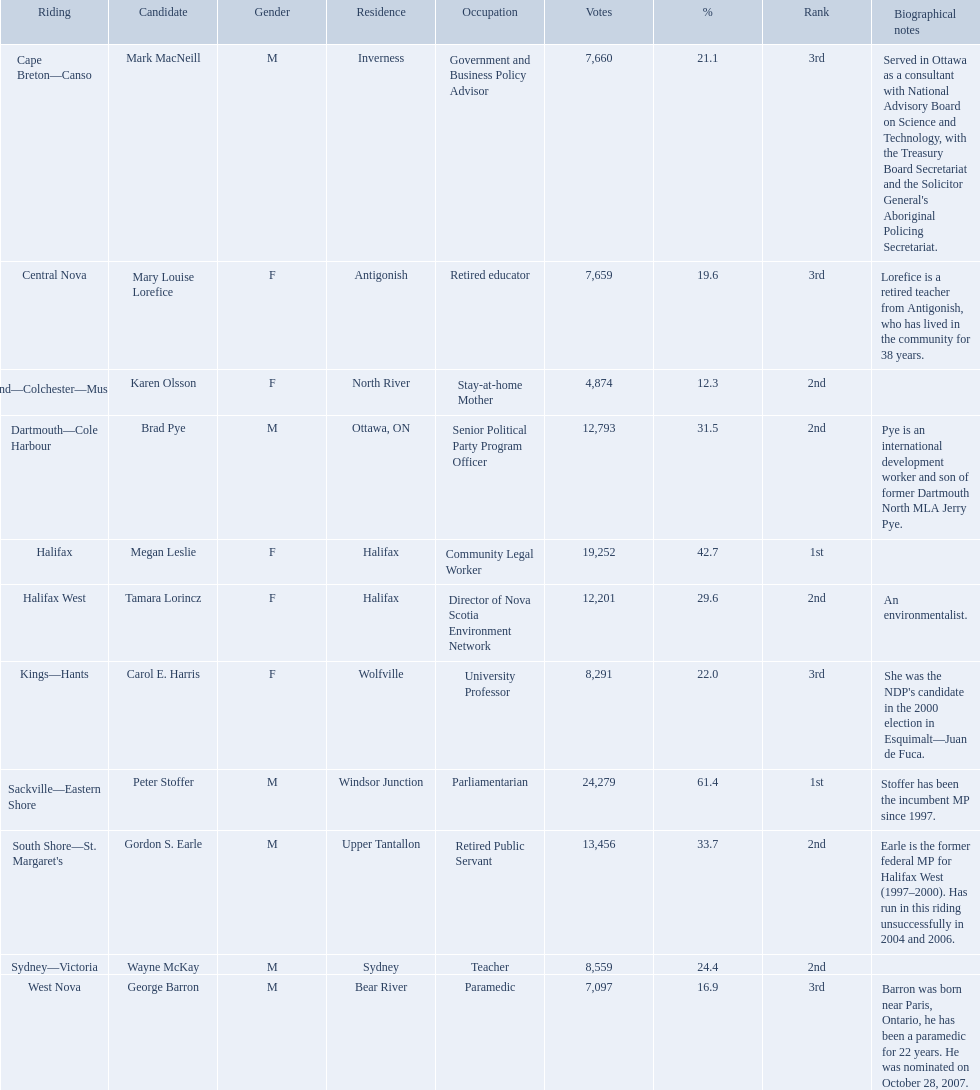How many votes did macneill receive? 7,660. How many votes did olsoon receive? 4,874. Between macneil and olsson, who received more votes? Mark MacNeill. Who are all the candidates? Mark MacNeill, Mary Louise Lorefice, Karen Olsson, Brad Pye, Megan Leslie, Tamara Lorincz, Carol E. Harris, Peter Stoffer, Gordon S. Earle, Wayne McKay, George Barron. How many votes did they receive? 7,660, 7,659, 4,874, 12,793, 19,252, 12,201, 8,291, 24,279, 13,456, 8,559, 7,097. And of those, how many were for megan leslie? 19,252. Which new democratic party candidates competed in the 2008 canadian federal election? Mark MacNeill, Mary Louise Lorefice, Karen Olsson, Brad Pye, Megan Leslie, Tamara Lorincz, Carol E. Harris, Peter Stoffer, Gordon S. Earle, Wayne McKay, George Barron. Of these candidates, which are female? Mary Louise Lorefice, Karen Olsson, Megan Leslie, Tamara Lorincz, Carol E. Harris. Which of these candidates is based in halifax? Megan Leslie, Tamara Lorincz. Of the remaining two, which was positioned 1st? Megan Leslie. How many votes did she secure? 19,252. Who are all the participants? Mark MacNeill, Mary Louise Lorefice, Karen Olsson, Brad Pye, Megan Leslie, Tamara Lorincz, Carol E. Harris, Peter Stoffer, Gordon S. Earle, Wayne McKay, George Barron. How many votes did they gather? 7,660, 7,659, 4,874, 12,793, 19,252, 12,201, 8,291, 24,279, 13,456, 8,559, 7,097. And of those, how many were supporting megan leslie? 19,252. Who were all of the new democratic party representatives during the 2008 canadian federal election? Mark MacNeill, Mary Louise Lorefice, Karen Olsson, Brad Pye, Megan Leslie, Tamara Lorincz, Carol E. Harris, Peter Stoffer, Gordon S. Earle, Wayne McKay, George Barron. Would you mind parsing the complete table? {'header': ['Riding', 'Candidate', 'Gender', 'Residence', 'Occupation', 'Votes', '%', 'Rank', 'Biographical notes'], 'rows': [['Cape Breton—Canso', 'Mark MacNeill', 'M', 'Inverness', 'Government and Business Policy Advisor', '7,660', '21.1', '3rd', "Served in Ottawa as a consultant with National Advisory Board on Science and Technology, with the Treasury Board Secretariat and the Solicitor General's Aboriginal Policing Secretariat."], ['Central Nova', 'Mary Louise Lorefice', 'F', 'Antigonish', 'Retired educator', '7,659', '19.6', '3rd', 'Lorefice is a retired teacher from Antigonish, who has lived in the community for 38 years.'], ['Cumberland—Colchester—Musquodoboit Valley', 'Karen Olsson', 'F', 'North River', 'Stay-at-home Mother', '4,874', '12.3', '2nd', ''], ['Dartmouth—Cole Harbour', 'Brad Pye', 'M', 'Ottawa, ON', 'Senior Political Party Program Officer', '12,793', '31.5', '2nd', 'Pye is an international development worker and son of former Dartmouth North MLA Jerry Pye.'], ['Halifax', 'Megan Leslie', 'F', 'Halifax', 'Community Legal Worker', '19,252', '42.7', '1st', ''], ['Halifax West', 'Tamara Lorincz', 'F', 'Halifax', 'Director of Nova Scotia Environment Network', '12,201', '29.6', '2nd', 'An environmentalist.'], ['Kings—Hants', 'Carol E. Harris', 'F', 'Wolfville', 'University Professor', '8,291', '22.0', '3rd', "She was the NDP's candidate in the 2000 election in Esquimalt—Juan de Fuca."], ['Sackville—Eastern Shore', 'Peter Stoffer', 'M', 'Windsor Junction', 'Parliamentarian', '24,279', '61.4', '1st', 'Stoffer has been the incumbent MP since 1997.'], ["South Shore—St. Margaret's", 'Gordon S. Earle', 'M', 'Upper Tantallon', 'Retired Public Servant', '13,456', '33.7', '2nd', 'Earle is the former federal MP for Halifax West (1997–2000). Has run in this riding unsuccessfully in 2004 and 2006.'], ['Sydney—Victoria', 'Wayne McKay', 'M', 'Sydney', 'Teacher', '8,559', '24.4', '2nd', ''], ['West Nova', 'George Barron', 'M', 'Bear River', 'Paramedic', '7,097', '16.9', '3rd', 'Barron was born near Paris, Ontario, he has been a paramedic for 22 years. He was nominated on October 28, 2007.']]} And between mark macneill and karen olsson, which candidate secured more votes? Mark MacNeill. Who are all the contenders? Mark MacNeill, Mary Louise Lorefice, Karen Olsson, Brad Pye, Megan Leslie, Tamara Lorincz, Carol E. Harris, Peter Stoffer, Gordon S. Earle, Wayne McKay, George Barron. How many ballots did they obtain? 7,660, 7,659, 4,874, 12,793, 19,252, 12,201, 8,291, 24,279, 13,456, 8,559, 7,097. And of those, how many were for megan leslie? 19,252. Who were the candidates representing the new democratic party in 2008? Mark MacNeill, Mary Louise Lorefice, Karen Olsson, Brad Pye, Megan Leslie, Tamara Lorincz, Carol E. Harris, Peter Stoffer, Gordon S. Earle, Wayne McKay, George Barron. Who secured the second highest vote count? Megan Leslie, Peter Stoffer. How many votes did she garner? 19,252. In 2008, who were the candidates for the new democratic party? Mark MacNeill, Mary Louise Lorefice, Karen Olsson, Brad Pye, Megan Leslie, Tamara Lorincz, Carol E. Harris, Peter Stoffer, Gordon S. Earle, Wayne McKay, George Barron. Who came in second place in terms of votes? Megan Leslie, Peter Stoffer. How many votes did she obtain? 19,252. How many votes were cast for macneill? 7,660. How many votes were cast for olsoon? 4,874. Between macneil and olsson, who had the greater number of votes? Mark MacNeill. During the 2008 canadian federal election, who were all the candidates representing the new democratic party? Mark MacNeill, Mary Louise Lorefice, Karen Olsson, Brad Pye, Megan Leslie, Tamara Lorincz, Carol E. Harris, Peter Stoffer, Gordon S. Earle, Wayne McKay, George Barron. Also, who got more votes between mark macneill and karen olsson? Mark MacNeill. Who were the new democratic party candidates in the 2008 canadian federal election? Mark MacNeill, Mary Louise Lorefice, Karen Olsson, Brad Pye, Megan Leslie, Tamara Lorincz, Carol E. Harris, Peter Stoffer, Gordon S. Earle, Wayne McKay, George Barron. Can you list the female candidates? Mary Louise Lorefice, Karen Olsson, Megan Leslie, Tamara Lorincz, Carol E. Harris. Which of these candidates had a home in halifax? Megan Leslie, Tamara Lorincz. Out of the other two, which one was ranked 1st? Megan Leslie. What was the number of votes she obtained? 19,252. 